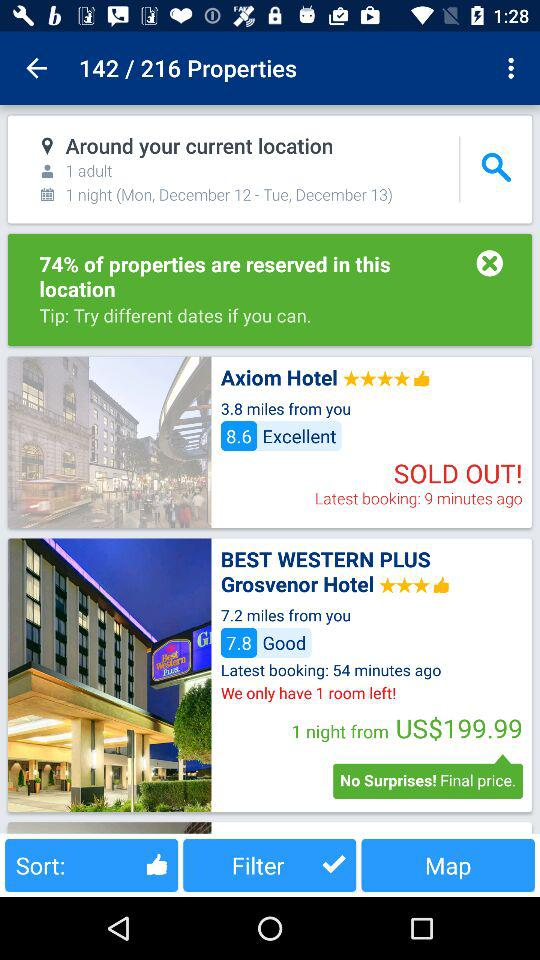What is the rating given to the "Axiom Hotel"? The rating is 8.6. 